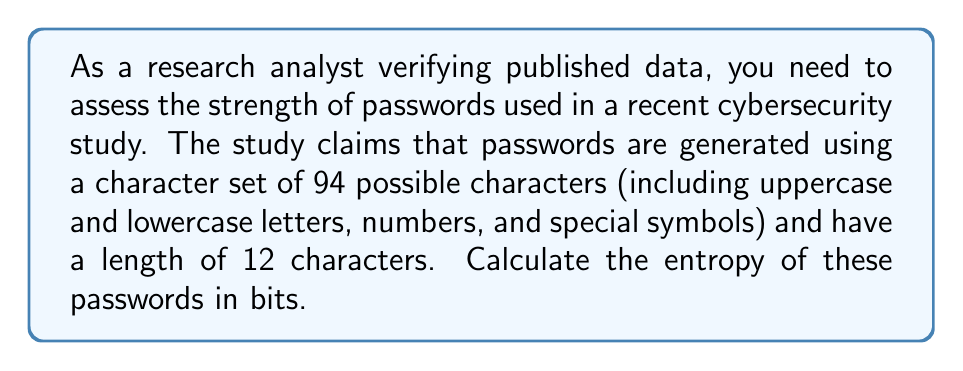Give your solution to this math problem. To calculate the entropy of a password, we use the formula:

$$H = L \times \log_2(N)$$

Where:
$H$ = entropy in bits
$L$ = length of the password
$N$ = size of the character set

Given:
$L = 12$ characters
$N = 94$ possible characters

Step 1: Substitute the values into the formula:
$$H = 12 \times \log_2(94)$$

Step 2: Calculate $\log_2(94)$:
$$\log_2(94) \approx 6.554589$$

Step 3: Multiply by the length:
$$H = 12 \times 6.554589 \approx 78.655068$$

Step 4: Round to two decimal places:
$$H \approx 78.66 \text{ bits}$$

This entropy value represents the theoretical maximum number of bits required to express all possible passwords with the given parameters.
Answer: 78.66 bits 